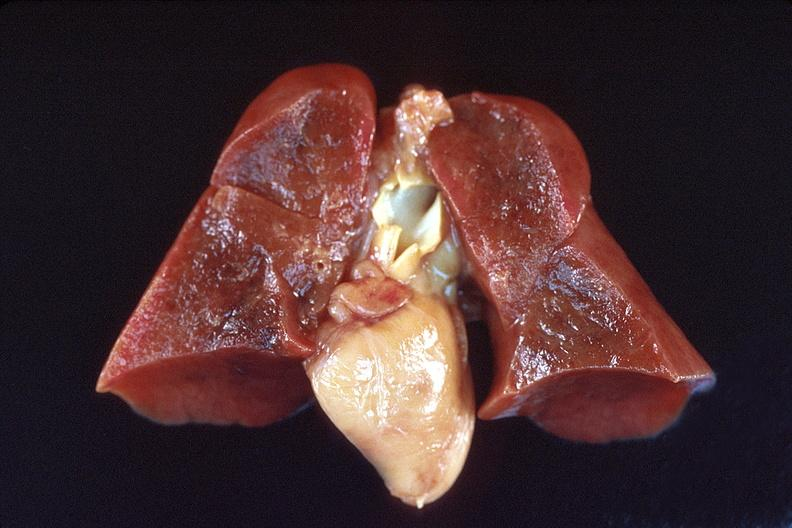does this image show lungs, hyaline membrane disease?
Answer the question using a single word or phrase. Yes 